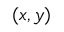<formula> <loc_0><loc_0><loc_500><loc_500>( x , y )</formula> 